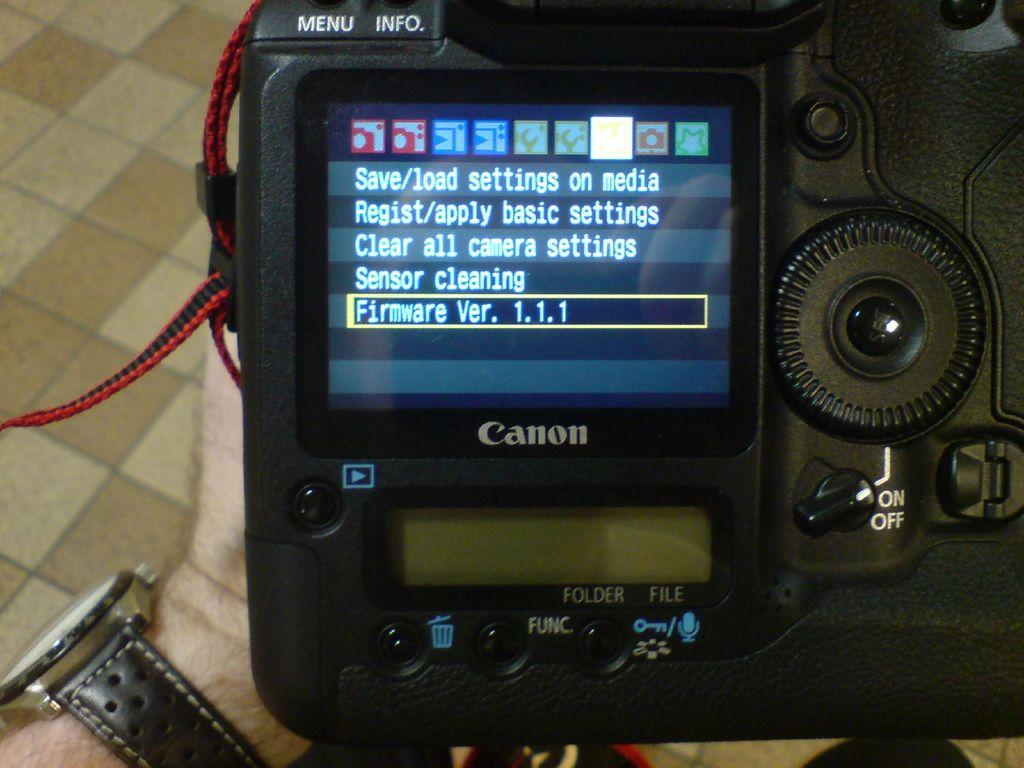<image>
Offer a succinct explanation of the picture presented. A screen can be seen on a camera with a Canon brand logo. 